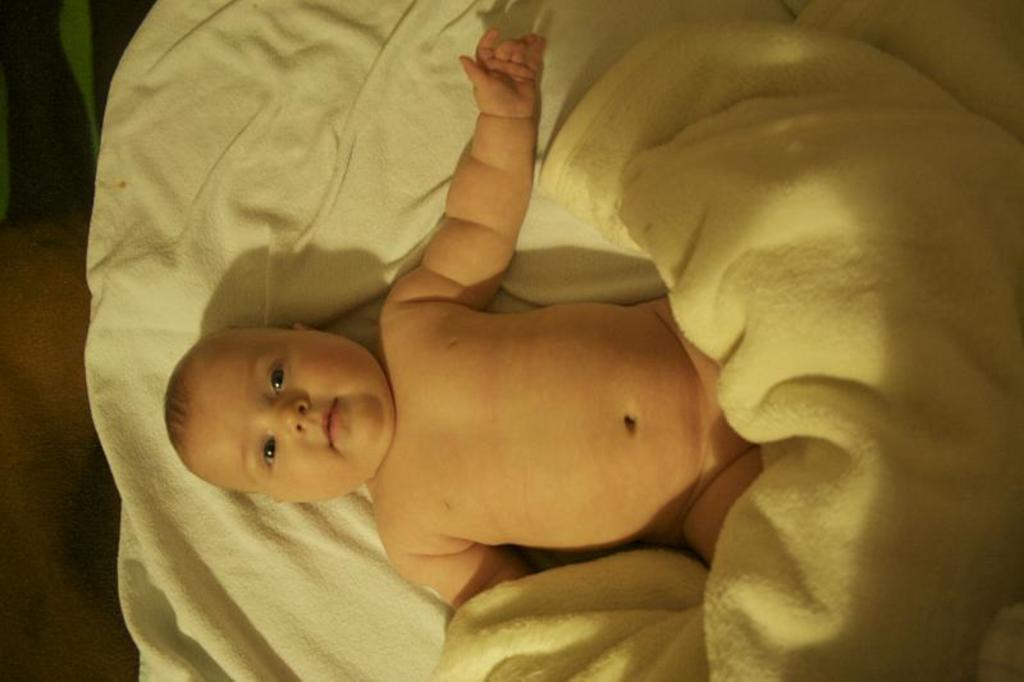What is the main subject of the image? There is a baby in the center of the image. What is the baby doing in the image? The baby is sleeping. Is there anything covering the baby in the image? Yes, there is a blanket on the baby. What time of day is it in the image, based on the position of the sun? The provided facts do not mention the position of the sun or any other time-related information, so it is impossible to determine the hour in the image. 